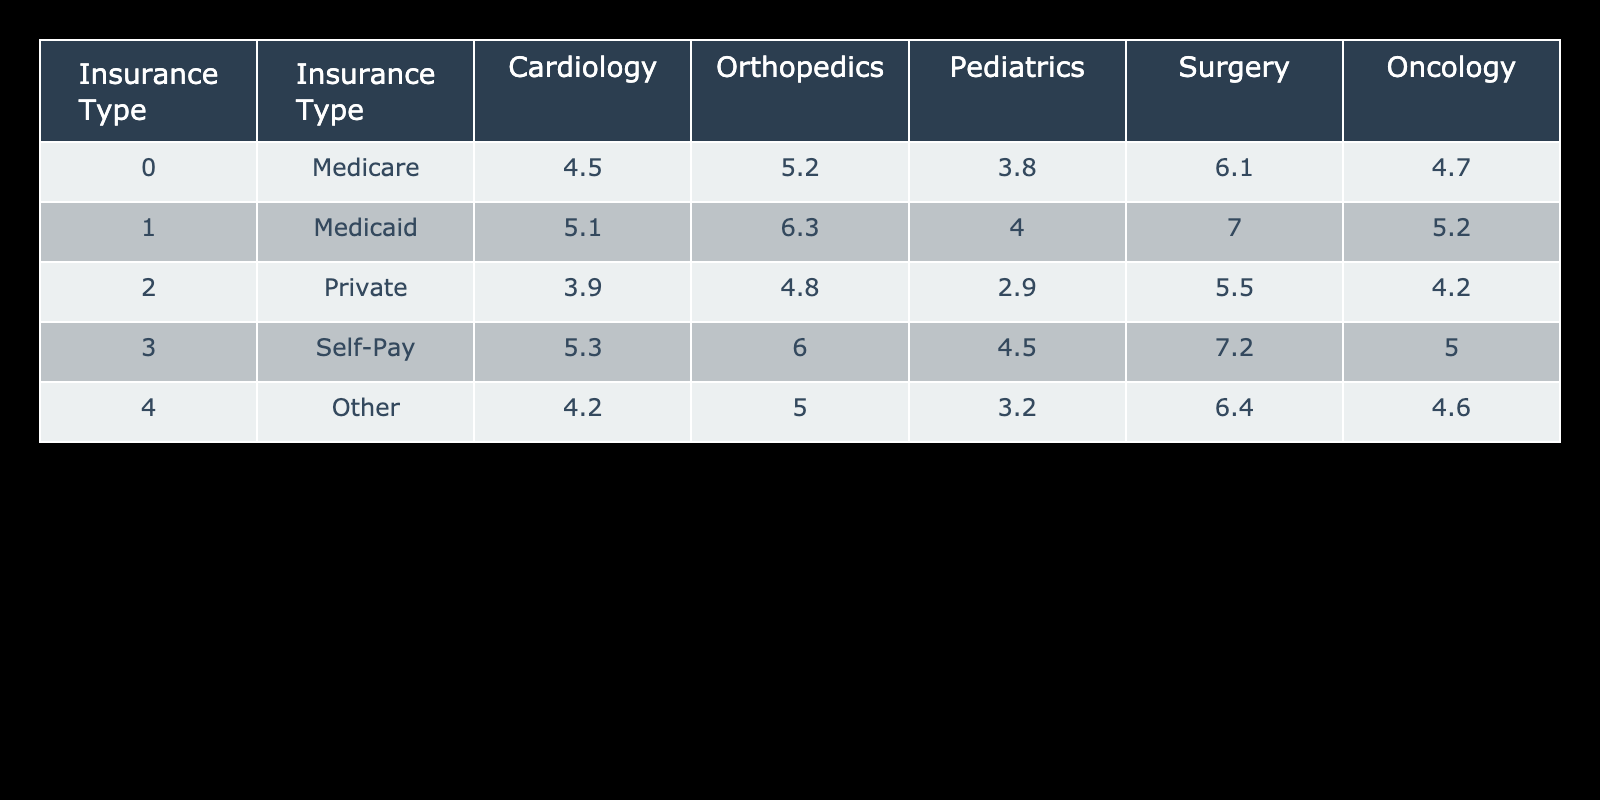What is the average length of stay for Medicare patients in Orthopedics? From the table, the length of stay for Medicare in Orthopedics is directly given as 5.2 days.
Answer: 5.2 Which insurance type has the longest average length of stay in Surgery? Looking at the Surgery column, the values are: Medicare 6.1, Medicaid 7.0, Private 5.5, Self-Pay 7.2, and Other 6.4. The maximum of these values is 7.2, which corresponds to Self-Pay.
Answer: Self-Pay What is the difference in average length of stay between Private and Medicaid patients in Cardiology? The average lengths of stay for Private and Medicaid in Cardiology are 3.9 and 5.1 days, respectively. To find the difference: 5.1 - 3.9 = 1.2 days.
Answer: 1.2 Is the average length of stay for Pediatric patients higher for Medicaid than for Other insurance types? For Pediatrics, Medicaid has an average length of stay of 4.0 days, and Other has 3.2 days. Since 4.0 is greater than 3.2, the statement is true.
Answer: Yes What is the total average length of stay for all insurance types in Oncology? The average lengths for Oncology are as follows: Medicare 4.7, Medicaid 5.2, Private 4.2, Self-Pay 5.0, Other 4.6. Summing these gives 4.7 + 5.2 + 4.2 + 5.0 + 4.6 = 23.7 days. To get the average, divide by 5 (the number of insurance types): 23.7 / 5 = 4.74.
Answer: 4.74 How many departments have an average length of stay greater than 5 days for Self-Pay patients? Looking at Self-Pay, the lengths of stay are: Cardiology 5.3, Orthopedics 6.0, Pediatrics 4.5, Surgery 7.2, and Oncology 5.0. The values greater than 5 are Cardiology, Orthopedics, and Surgery, totaling 3 departments.
Answer: 3 Which department shows the least variability in average length of stay across different insurance types? By reviewing the range of average lengths for each department: Cardiology ranges from 3.9 to 5.3, Orthopedics from 4.8 to 6.3, Pediatrics from 2.9 to 4.5, Surgery from 5.5 to 7.2, and Oncology from 4.2 to 5.2. The department with the smallest range is Oncology, with a range of 1.0 (5.2 - 4.2).
Answer: Oncology Which insurance type has the lowest average length of stay in Pediatrics? In Pediatrics, the average lengths of stay for the insurance types are: Medicare 3.8, Medicaid 4.0, Private 2.9, Self-Pay 4.5, Other 3.2. The lowest value is from Private, which is 2.9 days.
Answer: Private 